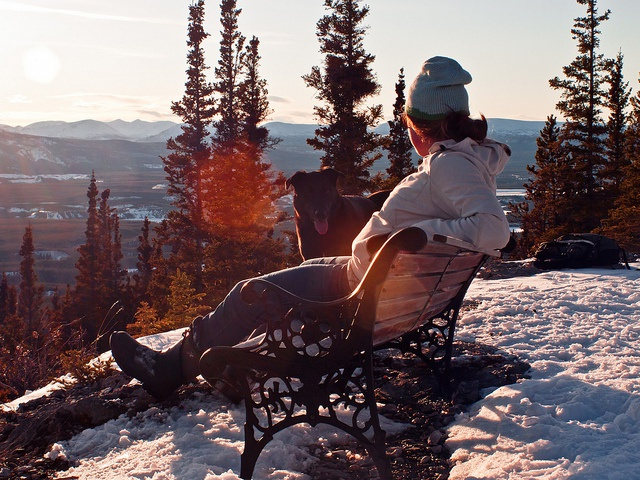Describe the objects in this image and their specific colors. I can see bench in white, black, maroon, gray, and brown tones, people in white, black, gray, and maroon tones, and dog in white, black, maroon, brown, and ivory tones in this image. 